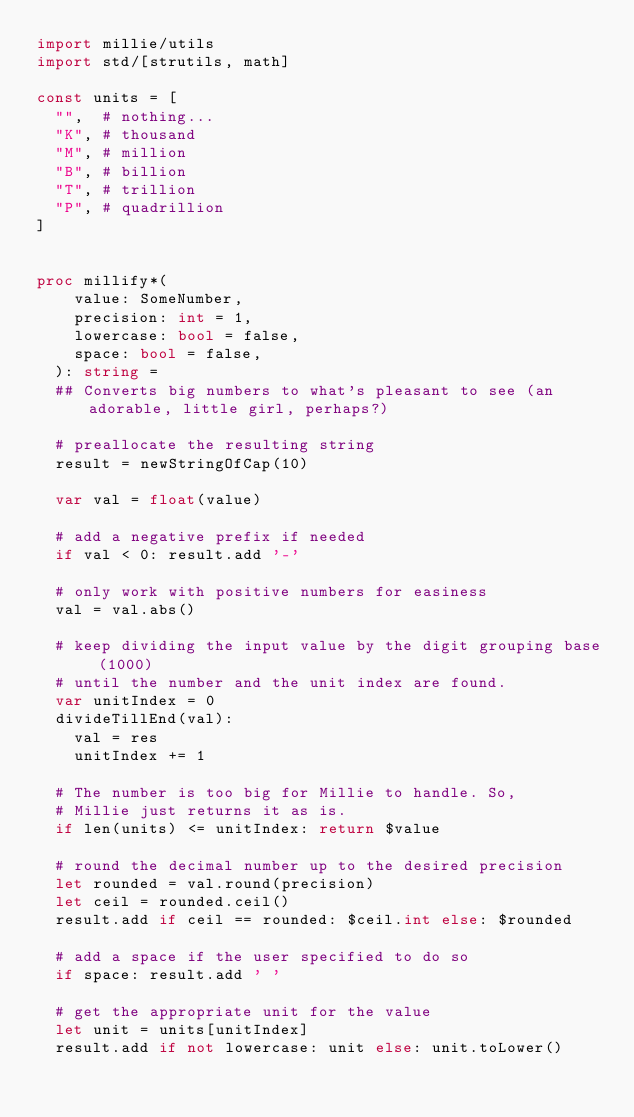<code> <loc_0><loc_0><loc_500><loc_500><_Nim_>import millie/utils
import std/[strutils, math]

const units = [
  "",  # nothing...
  "K", # thousand
  "M", # million
  "B", # billion
  "T", # trillion
  "P", # quadrillion
]


proc millify*(
    value: SomeNumber,
    precision: int = 1,
    lowercase: bool = false,
    space: bool = false,
  ): string =
  ## Converts big numbers to what's pleasant to see (an adorable, little girl, perhaps?)
  
  # preallocate the resulting string
  result = newStringOfCap(10)

  var val = float(value)

  # add a negative prefix if needed
  if val < 0: result.add '-'
  
  # only work with positive numbers for easiness
  val = val.abs()

  # keep dividing the input value by the digit grouping base (1000)
  # until the number and the unit index are found.
  var unitIndex = 0
  divideTillEnd(val):
    val = res
    unitIndex += 1

  # The number is too big for Millie to handle. So,
  # Millie just returns it as is.
  if len(units) <= unitIndex: return $value

  # round the decimal number up to the desired precision
  let rounded = val.round(precision)
  let ceil = rounded.ceil()
  result.add if ceil == rounded: $ceil.int else: $rounded

  # add a space if the user specified to do so
  if space: result.add ' '

  # get the appropriate unit for the value
  let unit = units[unitIndex]
  result.add if not lowercase: unit else: unit.toLower()
</code> 